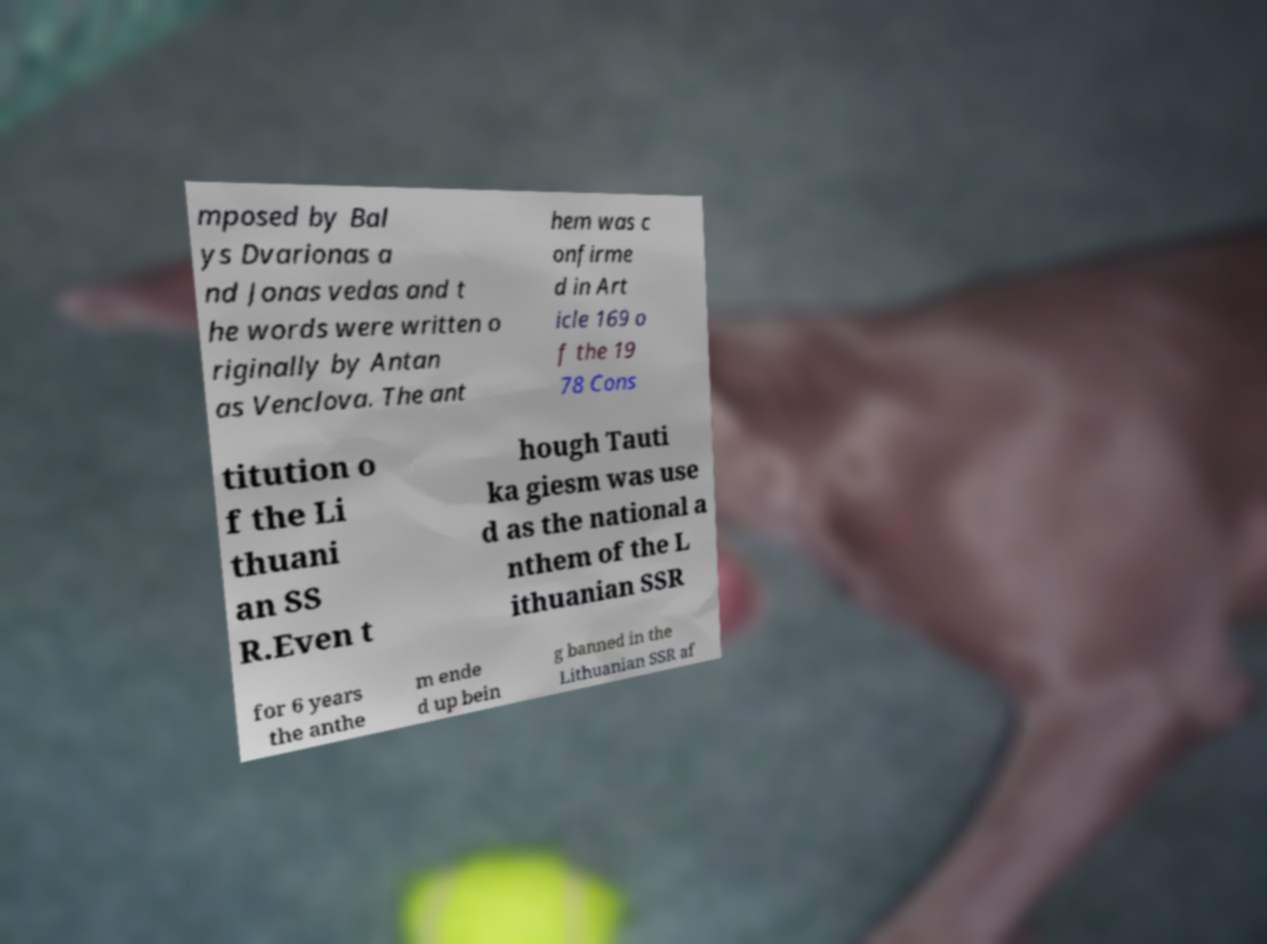Please read and relay the text visible in this image. What does it say? mposed by Bal ys Dvarionas a nd Jonas vedas and t he words were written o riginally by Antan as Venclova. The ant hem was c onfirme d in Art icle 169 o f the 19 78 Cons titution o f the Li thuani an SS R.Even t hough Tauti ka giesm was use d as the national a nthem of the L ithuanian SSR for 6 years the anthe m ende d up bein g banned in the Lithuanian SSR af 